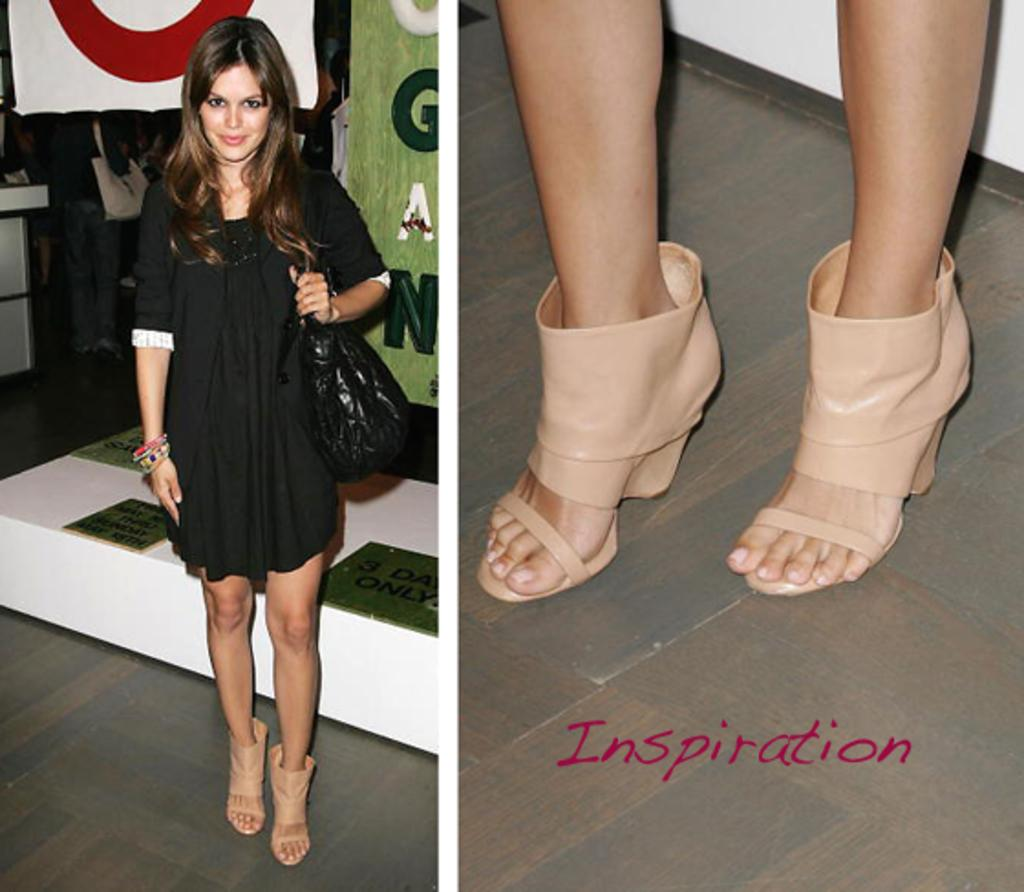Who or what is present in the image? There is a person in the image. What is the person wearing? The person is wearing a black dress and a black bag. What type of footwear can be seen in the image? There are sandals in cream color visible in the image. What type of steel object can be seen in the image? There is no steel object present in the image. Is there a hose visible in the image? No, there is no hose visible in the image. 